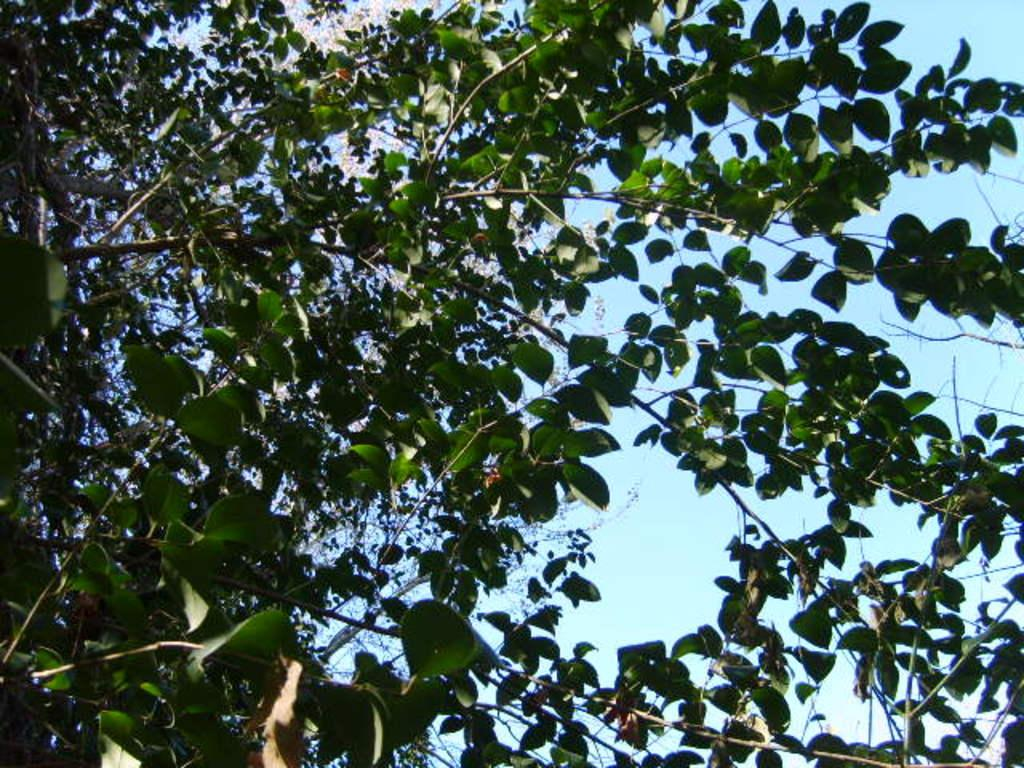What type of vegetation can be seen in the image? There are branches of trees in the image. What color are the leaves on the branches? The leaves on the branches are green. What can be seen in the background of the image? There are clouds in the background of the image. What color is the sky in the image? The sky is blue in the image. Can you see a flock of steam rising from the branches in the image? There is no steam present in the image; it features branches of trees with green leaves. Is there an attack happening in the image? There is no indication of an attack in the image; it shows branches of trees with green leaves, clouds in the background, and a blue sky. 